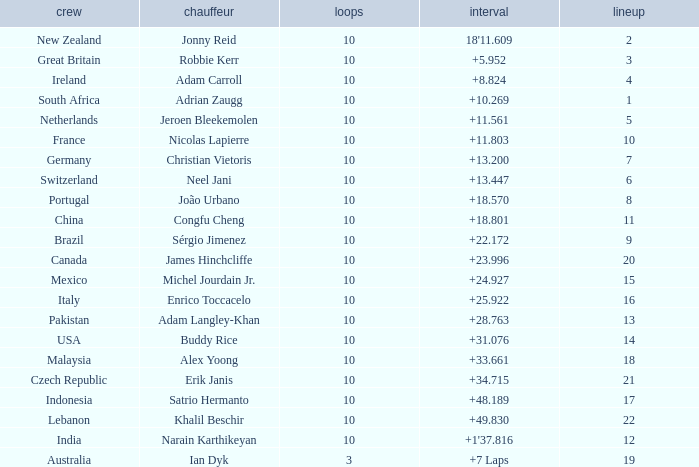What is the Grid number for the Team from Italy? 1.0. 